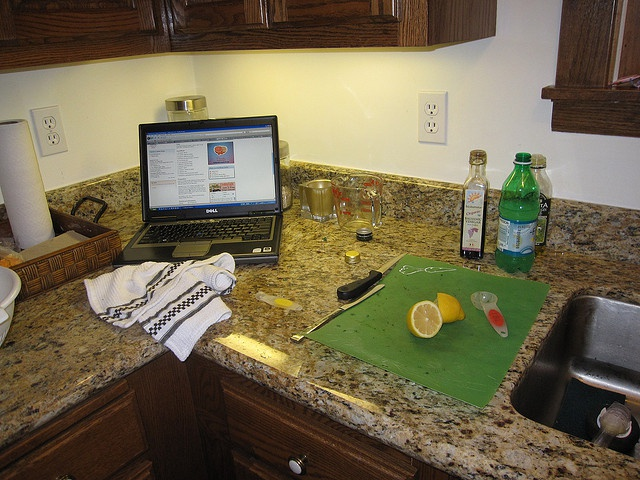Describe the objects in this image and their specific colors. I can see laptop in black, darkgray, lightgray, and olive tones, sink in black, gray, and darkgray tones, keyboard in black, olive, and gray tones, bottle in black, darkgreen, and gray tones, and cup in black and olive tones in this image. 